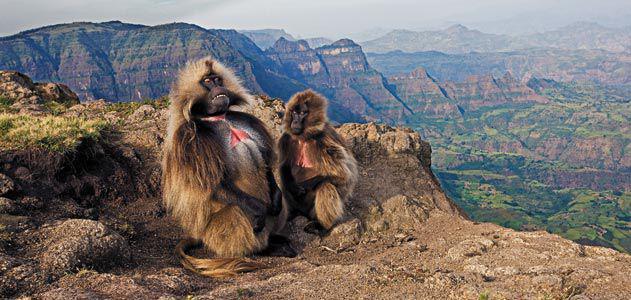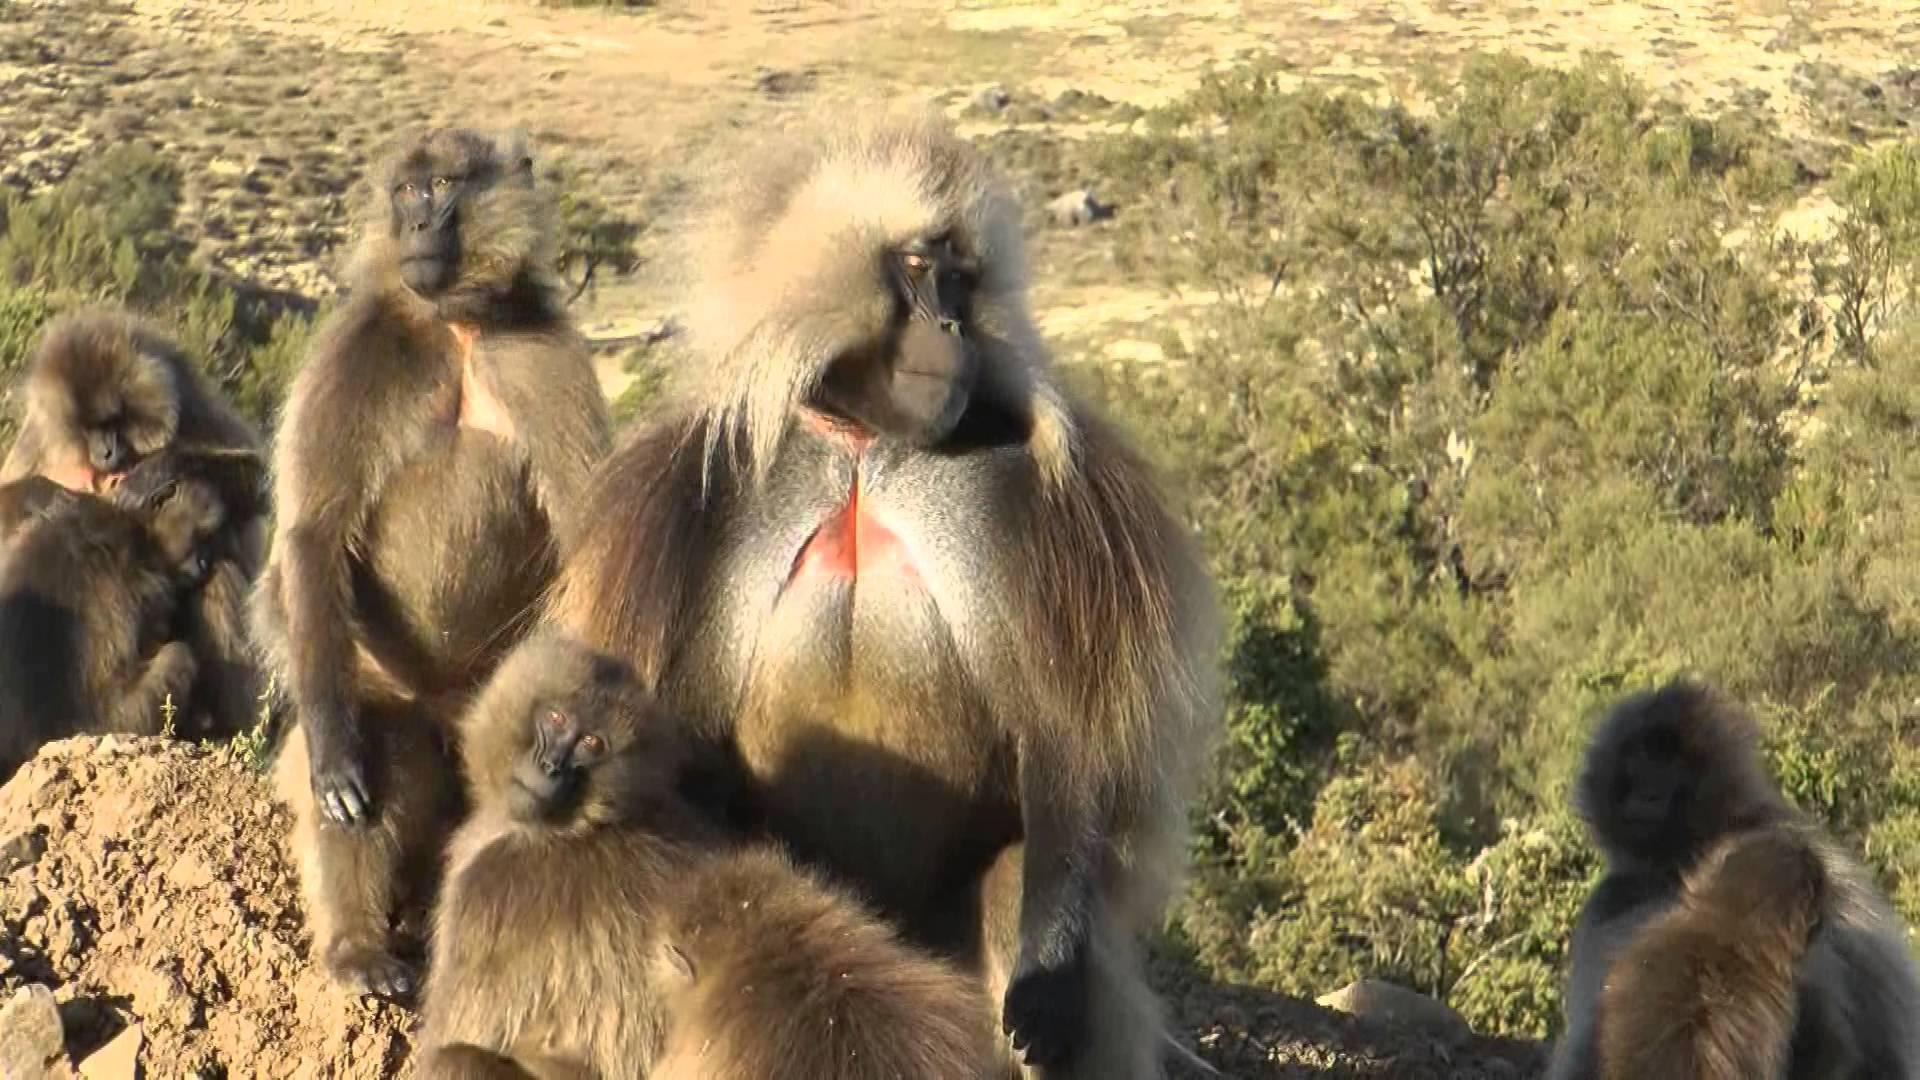The first image is the image on the left, the second image is the image on the right. For the images displayed, is the sentence "The left image contains exactly one baboon." factually correct? Answer yes or no. No. The first image is the image on the left, the second image is the image on the right. Evaluate the accuracy of this statement regarding the images: "The right image shows monkeys crouching on the grass and reaching toward the ground, with no human in the foreground.". Is it true? Answer yes or no. No. 